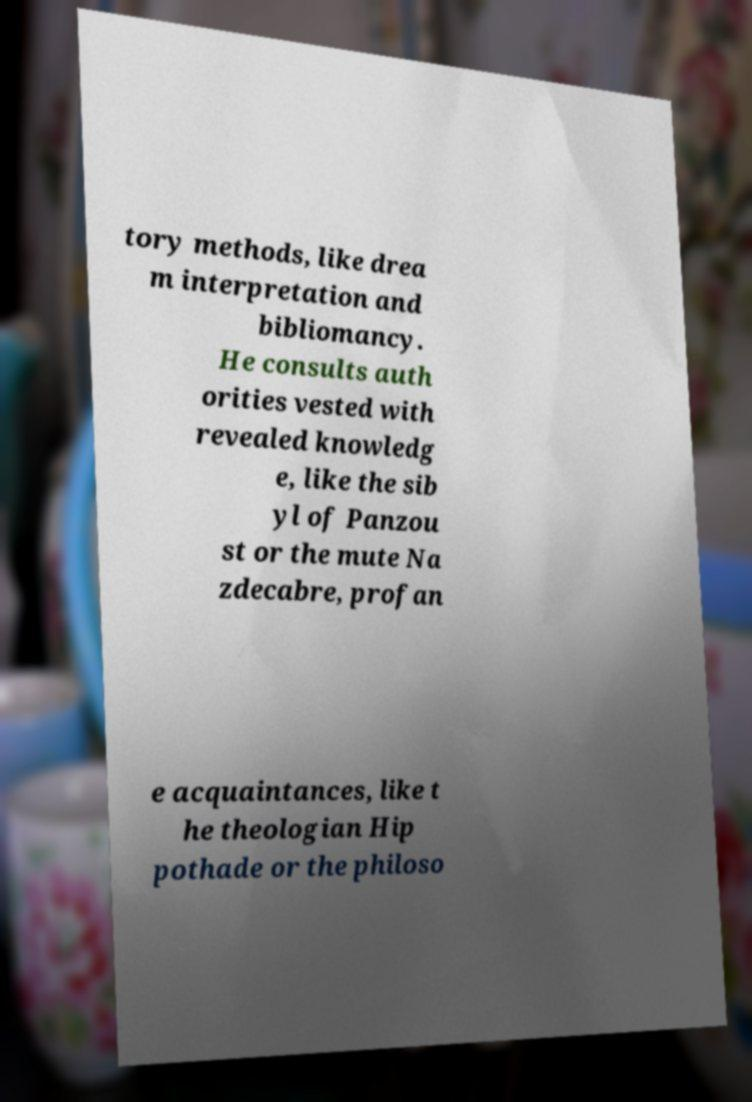Could you extract and type out the text from this image? tory methods, like drea m interpretation and bibliomancy. He consults auth orities vested with revealed knowledg e, like the sib yl of Panzou st or the mute Na zdecabre, profan e acquaintances, like t he theologian Hip pothade or the philoso 